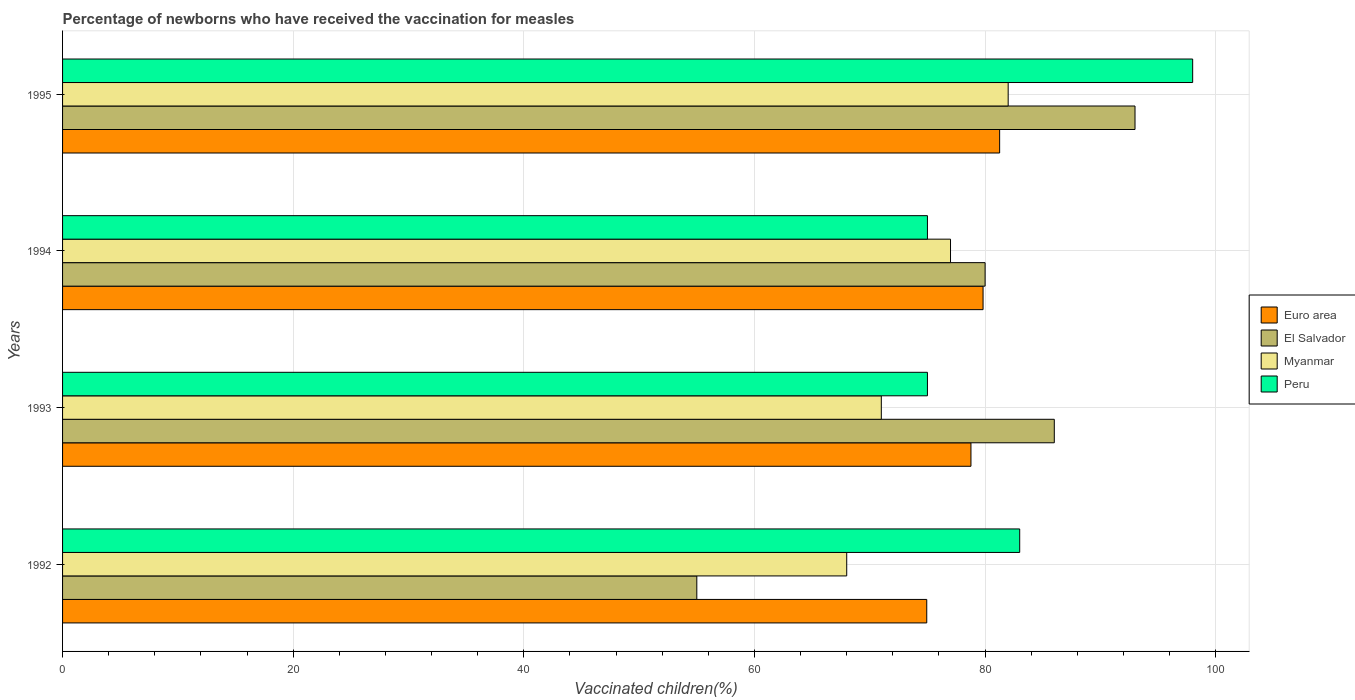How many groups of bars are there?
Your response must be concise. 4. Are the number of bars on each tick of the Y-axis equal?
Your answer should be very brief. Yes. How many bars are there on the 3rd tick from the top?
Offer a terse response. 4. How many bars are there on the 1st tick from the bottom?
Provide a short and direct response. 4. What is the label of the 3rd group of bars from the top?
Ensure brevity in your answer.  1993. What is the percentage of vaccinated children in Peru in 1995?
Your response must be concise. 98. Across all years, what is the maximum percentage of vaccinated children in El Salvador?
Offer a very short reply. 93. Across all years, what is the minimum percentage of vaccinated children in Euro area?
Offer a very short reply. 74.94. In which year was the percentage of vaccinated children in Peru maximum?
Offer a terse response. 1995. In which year was the percentage of vaccinated children in El Salvador minimum?
Make the answer very short. 1992. What is the total percentage of vaccinated children in Euro area in the graph?
Provide a succinct answer. 314.8. What is the difference between the percentage of vaccinated children in El Salvador in 1994 and that in 1995?
Offer a terse response. -13. What is the difference between the percentage of vaccinated children in Myanmar in 1993 and the percentage of vaccinated children in Euro area in 1994?
Keep it short and to the point. -8.82. What is the average percentage of vaccinated children in Peru per year?
Your answer should be very brief. 82.75. In the year 1995, what is the difference between the percentage of vaccinated children in Peru and percentage of vaccinated children in El Salvador?
Offer a very short reply. 5. What is the ratio of the percentage of vaccinated children in Euro area in 1992 to that in 1995?
Your answer should be compact. 0.92. Is the percentage of vaccinated children in Myanmar in 1993 less than that in 1995?
Your answer should be compact. Yes. Is the difference between the percentage of vaccinated children in Peru in 1992 and 1993 greater than the difference between the percentage of vaccinated children in El Salvador in 1992 and 1993?
Provide a short and direct response. Yes. What is the difference between the highest and the second highest percentage of vaccinated children in Peru?
Your answer should be compact. 15. What is the difference between the highest and the lowest percentage of vaccinated children in Myanmar?
Provide a short and direct response. 14. In how many years, is the percentage of vaccinated children in Peru greater than the average percentage of vaccinated children in Peru taken over all years?
Provide a succinct answer. 2. Is it the case that in every year, the sum of the percentage of vaccinated children in El Salvador and percentage of vaccinated children in Euro area is greater than the sum of percentage of vaccinated children in Myanmar and percentage of vaccinated children in Peru?
Keep it short and to the point. No. What does the 3rd bar from the bottom in 1992 represents?
Your answer should be compact. Myanmar. Are all the bars in the graph horizontal?
Your answer should be very brief. Yes. How many years are there in the graph?
Your answer should be very brief. 4. What is the difference between two consecutive major ticks on the X-axis?
Give a very brief answer. 20. Are the values on the major ticks of X-axis written in scientific E-notation?
Your answer should be very brief. No. Does the graph contain any zero values?
Offer a very short reply. No. Does the graph contain grids?
Ensure brevity in your answer.  Yes. How many legend labels are there?
Offer a very short reply. 4. How are the legend labels stacked?
Your answer should be very brief. Vertical. What is the title of the graph?
Your response must be concise. Percentage of newborns who have received the vaccination for measles. Does "Croatia" appear as one of the legend labels in the graph?
Keep it short and to the point. No. What is the label or title of the X-axis?
Make the answer very short. Vaccinated children(%). What is the Vaccinated children(%) of Euro area in 1992?
Provide a succinct answer. 74.94. What is the Vaccinated children(%) of El Salvador in 1992?
Your answer should be compact. 55. What is the Vaccinated children(%) in Euro area in 1993?
Your answer should be very brief. 78.77. What is the Vaccinated children(%) of Euro area in 1994?
Provide a short and direct response. 79.82. What is the Vaccinated children(%) in Myanmar in 1994?
Your response must be concise. 77. What is the Vaccinated children(%) of Euro area in 1995?
Your answer should be compact. 81.26. What is the Vaccinated children(%) in El Salvador in 1995?
Your answer should be compact. 93. Across all years, what is the maximum Vaccinated children(%) of Euro area?
Your answer should be compact. 81.26. Across all years, what is the maximum Vaccinated children(%) in El Salvador?
Offer a terse response. 93. Across all years, what is the maximum Vaccinated children(%) in Peru?
Your response must be concise. 98. Across all years, what is the minimum Vaccinated children(%) in Euro area?
Ensure brevity in your answer.  74.94. Across all years, what is the minimum Vaccinated children(%) in Peru?
Your answer should be compact. 75. What is the total Vaccinated children(%) of Euro area in the graph?
Provide a succinct answer. 314.8. What is the total Vaccinated children(%) in El Salvador in the graph?
Your response must be concise. 314. What is the total Vaccinated children(%) of Myanmar in the graph?
Provide a succinct answer. 298. What is the total Vaccinated children(%) in Peru in the graph?
Provide a succinct answer. 331. What is the difference between the Vaccinated children(%) in Euro area in 1992 and that in 1993?
Ensure brevity in your answer.  -3.83. What is the difference between the Vaccinated children(%) of El Salvador in 1992 and that in 1993?
Make the answer very short. -31. What is the difference between the Vaccinated children(%) of Peru in 1992 and that in 1993?
Make the answer very short. 8. What is the difference between the Vaccinated children(%) of Euro area in 1992 and that in 1994?
Your answer should be compact. -4.88. What is the difference between the Vaccinated children(%) in Euro area in 1992 and that in 1995?
Offer a terse response. -6.32. What is the difference between the Vaccinated children(%) in El Salvador in 1992 and that in 1995?
Provide a succinct answer. -38. What is the difference between the Vaccinated children(%) in Euro area in 1993 and that in 1994?
Make the answer very short. -1.05. What is the difference between the Vaccinated children(%) in El Salvador in 1993 and that in 1994?
Give a very brief answer. 6. What is the difference between the Vaccinated children(%) of Myanmar in 1993 and that in 1994?
Provide a succinct answer. -6. What is the difference between the Vaccinated children(%) in Peru in 1993 and that in 1994?
Your response must be concise. 0. What is the difference between the Vaccinated children(%) of Euro area in 1993 and that in 1995?
Your response must be concise. -2.49. What is the difference between the Vaccinated children(%) in El Salvador in 1993 and that in 1995?
Your answer should be compact. -7. What is the difference between the Vaccinated children(%) in Myanmar in 1993 and that in 1995?
Offer a very short reply. -11. What is the difference between the Vaccinated children(%) of Euro area in 1994 and that in 1995?
Provide a short and direct response. -1.44. What is the difference between the Vaccinated children(%) of El Salvador in 1994 and that in 1995?
Ensure brevity in your answer.  -13. What is the difference between the Vaccinated children(%) in Peru in 1994 and that in 1995?
Your response must be concise. -23. What is the difference between the Vaccinated children(%) of Euro area in 1992 and the Vaccinated children(%) of El Salvador in 1993?
Your answer should be very brief. -11.06. What is the difference between the Vaccinated children(%) of Euro area in 1992 and the Vaccinated children(%) of Myanmar in 1993?
Your answer should be compact. 3.94. What is the difference between the Vaccinated children(%) of Euro area in 1992 and the Vaccinated children(%) of Peru in 1993?
Your answer should be very brief. -0.06. What is the difference between the Vaccinated children(%) of El Salvador in 1992 and the Vaccinated children(%) of Peru in 1993?
Give a very brief answer. -20. What is the difference between the Vaccinated children(%) in Myanmar in 1992 and the Vaccinated children(%) in Peru in 1993?
Give a very brief answer. -7. What is the difference between the Vaccinated children(%) in Euro area in 1992 and the Vaccinated children(%) in El Salvador in 1994?
Provide a short and direct response. -5.06. What is the difference between the Vaccinated children(%) in Euro area in 1992 and the Vaccinated children(%) in Myanmar in 1994?
Give a very brief answer. -2.06. What is the difference between the Vaccinated children(%) in Euro area in 1992 and the Vaccinated children(%) in Peru in 1994?
Give a very brief answer. -0.06. What is the difference between the Vaccinated children(%) of Euro area in 1992 and the Vaccinated children(%) of El Salvador in 1995?
Offer a terse response. -18.06. What is the difference between the Vaccinated children(%) in Euro area in 1992 and the Vaccinated children(%) in Myanmar in 1995?
Your answer should be very brief. -7.06. What is the difference between the Vaccinated children(%) in Euro area in 1992 and the Vaccinated children(%) in Peru in 1995?
Provide a succinct answer. -23.06. What is the difference between the Vaccinated children(%) in El Salvador in 1992 and the Vaccinated children(%) in Peru in 1995?
Offer a terse response. -43. What is the difference between the Vaccinated children(%) of Myanmar in 1992 and the Vaccinated children(%) of Peru in 1995?
Offer a terse response. -30. What is the difference between the Vaccinated children(%) of Euro area in 1993 and the Vaccinated children(%) of El Salvador in 1994?
Keep it short and to the point. -1.23. What is the difference between the Vaccinated children(%) in Euro area in 1993 and the Vaccinated children(%) in Myanmar in 1994?
Keep it short and to the point. 1.77. What is the difference between the Vaccinated children(%) in Euro area in 1993 and the Vaccinated children(%) in Peru in 1994?
Your response must be concise. 3.77. What is the difference between the Vaccinated children(%) in El Salvador in 1993 and the Vaccinated children(%) in Myanmar in 1994?
Provide a short and direct response. 9. What is the difference between the Vaccinated children(%) in Myanmar in 1993 and the Vaccinated children(%) in Peru in 1994?
Give a very brief answer. -4. What is the difference between the Vaccinated children(%) of Euro area in 1993 and the Vaccinated children(%) of El Salvador in 1995?
Your answer should be very brief. -14.23. What is the difference between the Vaccinated children(%) of Euro area in 1993 and the Vaccinated children(%) of Myanmar in 1995?
Offer a terse response. -3.23. What is the difference between the Vaccinated children(%) of Euro area in 1993 and the Vaccinated children(%) of Peru in 1995?
Your answer should be compact. -19.23. What is the difference between the Vaccinated children(%) in El Salvador in 1993 and the Vaccinated children(%) in Myanmar in 1995?
Give a very brief answer. 4. What is the difference between the Vaccinated children(%) in El Salvador in 1993 and the Vaccinated children(%) in Peru in 1995?
Make the answer very short. -12. What is the difference between the Vaccinated children(%) of Euro area in 1994 and the Vaccinated children(%) of El Salvador in 1995?
Keep it short and to the point. -13.18. What is the difference between the Vaccinated children(%) of Euro area in 1994 and the Vaccinated children(%) of Myanmar in 1995?
Keep it short and to the point. -2.18. What is the difference between the Vaccinated children(%) in Euro area in 1994 and the Vaccinated children(%) in Peru in 1995?
Make the answer very short. -18.18. What is the difference between the Vaccinated children(%) in El Salvador in 1994 and the Vaccinated children(%) in Peru in 1995?
Ensure brevity in your answer.  -18. What is the average Vaccinated children(%) in Euro area per year?
Provide a short and direct response. 78.7. What is the average Vaccinated children(%) of El Salvador per year?
Your response must be concise. 78.5. What is the average Vaccinated children(%) in Myanmar per year?
Your answer should be very brief. 74.5. What is the average Vaccinated children(%) in Peru per year?
Make the answer very short. 82.75. In the year 1992, what is the difference between the Vaccinated children(%) in Euro area and Vaccinated children(%) in El Salvador?
Your answer should be compact. 19.94. In the year 1992, what is the difference between the Vaccinated children(%) in Euro area and Vaccinated children(%) in Myanmar?
Offer a terse response. 6.94. In the year 1992, what is the difference between the Vaccinated children(%) of Euro area and Vaccinated children(%) of Peru?
Your answer should be compact. -8.06. In the year 1992, what is the difference between the Vaccinated children(%) in El Salvador and Vaccinated children(%) in Myanmar?
Your answer should be very brief. -13. In the year 1992, what is the difference between the Vaccinated children(%) in El Salvador and Vaccinated children(%) in Peru?
Provide a short and direct response. -28. In the year 1993, what is the difference between the Vaccinated children(%) of Euro area and Vaccinated children(%) of El Salvador?
Keep it short and to the point. -7.23. In the year 1993, what is the difference between the Vaccinated children(%) in Euro area and Vaccinated children(%) in Myanmar?
Offer a very short reply. 7.77. In the year 1993, what is the difference between the Vaccinated children(%) in Euro area and Vaccinated children(%) in Peru?
Provide a succinct answer. 3.77. In the year 1993, what is the difference between the Vaccinated children(%) in El Salvador and Vaccinated children(%) in Myanmar?
Ensure brevity in your answer.  15. In the year 1993, what is the difference between the Vaccinated children(%) of El Salvador and Vaccinated children(%) of Peru?
Give a very brief answer. 11. In the year 1994, what is the difference between the Vaccinated children(%) in Euro area and Vaccinated children(%) in El Salvador?
Your answer should be very brief. -0.18. In the year 1994, what is the difference between the Vaccinated children(%) in Euro area and Vaccinated children(%) in Myanmar?
Your answer should be compact. 2.82. In the year 1994, what is the difference between the Vaccinated children(%) of Euro area and Vaccinated children(%) of Peru?
Keep it short and to the point. 4.82. In the year 1995, what is the difference between the Vaccinated children(%) of Euro area and Vaccinated children(%) of El Salvador?
Offer a very short reply. -11.74. In the year 1995, what is the difference between the Vaccinated children(%) in Euro area and Vaccinated children(%) in Myanmar?
Your response must be concise. -0.74. In the year 1995, what is the difference between the Vaccinated children(%) of Euro area and Vaccinated children(%) of Peru?
Give a very brief answer. -16.74. What is the ratio of the Vaccinated children(%) of Euro area in 1992 to that in 1993?
Your response must be concise. 0.95. What is the ratio of the Vaccinated children(%) of El Salvador in 1992 to that in 1993?
Provide a succinct answer. 0.64. What is the ratio of the Vaccinated children(%) in Myanmar in 1992 to that in 1993?
Make the answer very short. 0.96. What is the ratio of the Vaccinated children(%) of Peru in 1992 to that in 1993?
Make the answer very short. 1.11. What is the ratio of the Vaccinated children(%) of Euro area in 1992 to that in 1994?
Your response must be concise. 0.94. What is the ratio of the Vaccinated children(%) in El Salvador in 1992 to that in 1994?
Your response must be concise. 0.69. What is the ratio of the Vaccinated children(%) in Myanmar in 1992 to that in 1994?
Offer a very short reply. 0.88. What is the ratio of the Vaccinated children(%) in Peru in 1992 to that in 1994?
Offer a very short reply. 1.11. What is the ratio of the Vaccinated children(%) in Euro area in 1992 to that in 1995?
Provide a short and direct response. 0.92. What is the ratio of the Vaccinated children(%) of El Salvador in 1992 to that in 1995?
Provide a short and direct response. 0.59. What is the ratio of the Vaccinated children(%) of Myanmar in 1992 to that in 1995?
Your answer should be compact. 0.83. What is the ratio of the Vaccinated children(%) in Peru in 1992 to that in 1995?
Your response must be concise. 0.85. What is the ratio of the Vaccinated children(%) of Euro area in 1993 to that in 1994?
Offer a very short reply. 0.99. What is the ratio of the Vaccinated children(%) of El Salvador in 1993 to that in 1994?
Your answer should be compact. 1.07. What is the ratio of the Vaccinated children(%) in Myanmar in 1993 to that in 1994?
Provide a short and direct response. 0.92. What is the ratio of the Vaccinated children(%) in Euro area in 1993 to that in 1995?
Give a very brief answer. 0.97. What is the ratio of the Vaccinated children(%) of El Salvador in 1993 to that in 1995?
Your response must be concise. 0.92. What is the ratio of the Vaccinated children(%) of Myanmar in 1993 to that in 1995?
Your response must be concise. 0.87. What is the ratio of the Vaccinated children(%) in Peru in 1993 to that in 1995?
Make the answer very short. 0.77. What is the ratio of the Vaccinated children(%) of Euro area in 1994 to that in 1995?
Your answer should be compact. 0.98. What is the ratio of the Vaccinated children(%) of El Salvador in 1994 to that in 1995?
Offer a terse response. 0.86. What is the ratio of the Vaccinated children(%) of Myanmar in 1994 to that in 1995?
Keep it short and to the point. 0.94. What is the ratio of the Vaccinated children(%) in Peru in 1994 to that in 1995?
Provide a succinct answer. 0.77. What is the difference between the highest and the second highest Vaccinated children(%) of Euro area?
Your answer should be very brief. 1.44. What is the difference between the highest and the second highest Vaccinated children(%) in Myanmar?
Ensure brevity in your answer.  5. What is the difference between the highest and the lowest Vaccinated children(%) in Euro area?
Keep it short and to the point. 6.32. What is the difference between the highest and the lowest Vaccinated children(%) of Myanmar?
Provide a short and direct response. 14. 